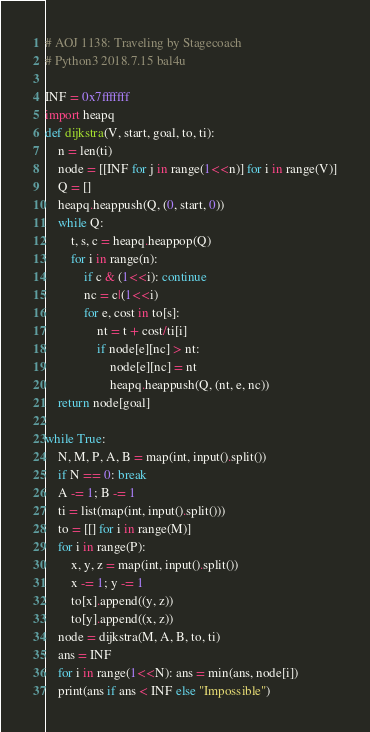<code> <loc_0><loc_0><loc_500><loc_500><_Python_># AOJ 1138: Traveling by Stagecoach
# Python3 2018.7.15 bal4u

INF = 0x7fffffff
import heapq
def dijkstra(V, start, goal, to, ti):
	n = len(ti)
	node = [[INF for j in range(1<<n)] for i in range(V)]
	Q = []
	heapq.heappush(Q, (0, start, 0))
	while Q:
		t, s, c = heapq.heappop(Q)
		for i in range(n):
			if c & (1<<i): continue
			nc = c|(1<<i)
			for e, cost in to[s]:
				nt = t + cost/ti[i]
				if node[e][nc] > nt:
					node[e][nc] = nt
					heapq.heappush(Q, (nt, e, nc))
	return node[goal]
	
while True:
	N, M, P, A, B = map(int, input().split())
	if N == 0: break
	A -= 1; B -= 1
	ti = list(map(int, input().split()))
	to = [[] for i in range(M)]
	for i in range(P):
		x, y, z = map(int, input().split())
		x -= 1; y -= 1
		to[x].append((y, z))
		to[y].append((x, z))
	node = dijkstra(M, A, B, to, ti)
	ans = INF
	for i in range(1<<N): ans = min(ans, node[i])
	print(ans if ans < INF else "Impossible")

</code> 